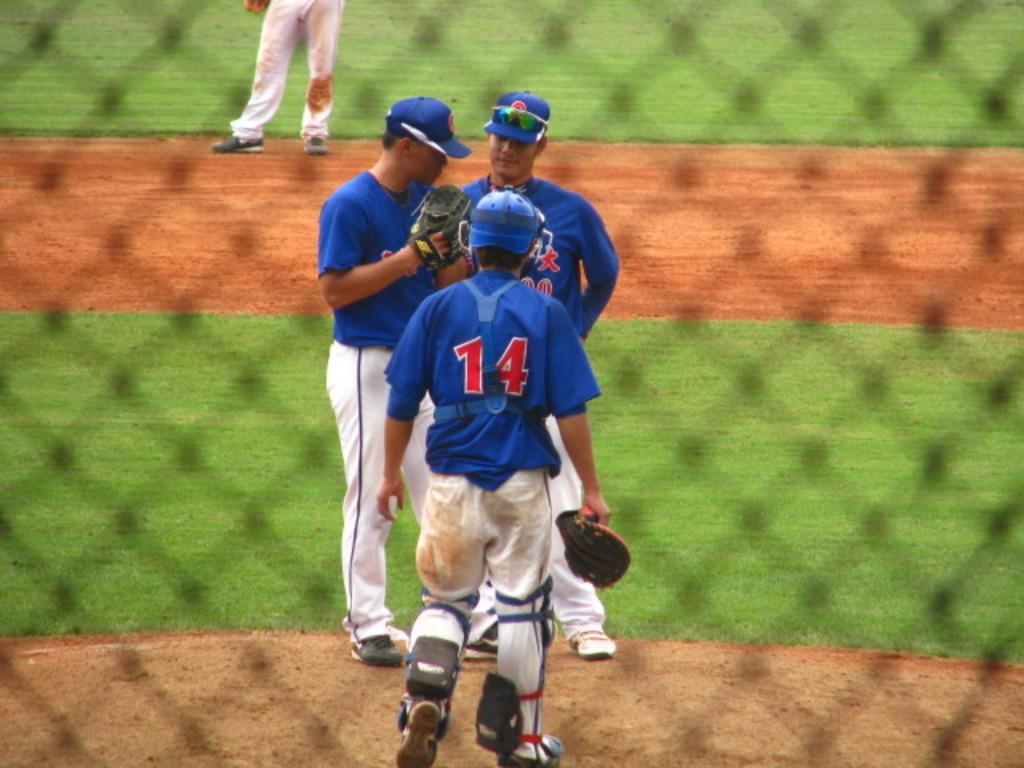What is the catcher's jersey number?
Ensure brevity in your answer.  14. Is the catcher wearing number 14?
Ensure brevity in your answer.  Yes. 